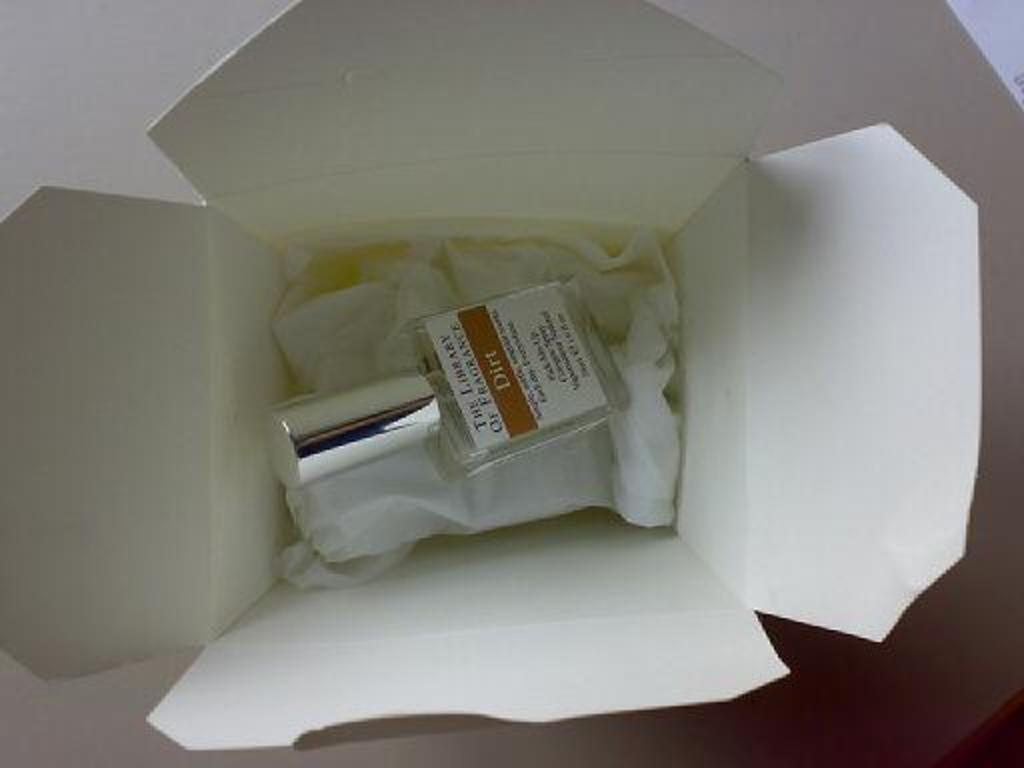<image>
Relay a brief, clear account of the picture shown. A small bottle of Dirt fragrance is in a small white box. 